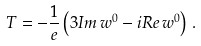Convert formula to latex. <formula><loc_0><loc_0><loc_500><loc_500>T = - \frac { 1 } { e } \left ( 3 I m \, w ^ { 0 } - i R e \, w ^ { 0 } \right ) \, .</formula> 